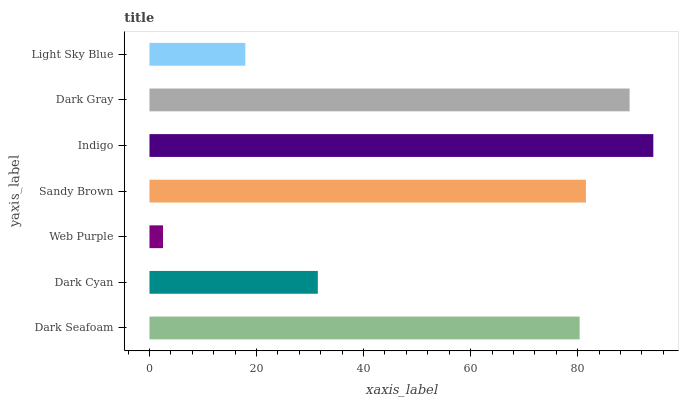Is Web Purple the minimum?
Answer yes or no. Yes. Is Indigo the maximum?
Answer yes or no. Yes. Is Dark Cyan the minimum?
Answer yes or no. No. Is Dark Cyan the maximum?
Answer yes or no. No. Is Dark Seafoam greater than Dark Cyan?
Answer yes or no. Yes. Is Dark Cyan less than Dark Seafoam?
Answer yes or no. Yes. Is Dark Cyan greater than Dark Seafoam?
Answer yes or no. No. Is Dark Seafoam less than Dark Cyan?
Answer yes or no. No. Is Dark Seafoam the high median?
Answer yes or no. Yes. Is Dark Seafoam the low median?
Answer yes or no. Yes. Is Light Sky Blue the high median?
Answer yes or no. No. Is Indigo the low median?
Answer yes or no. No. 